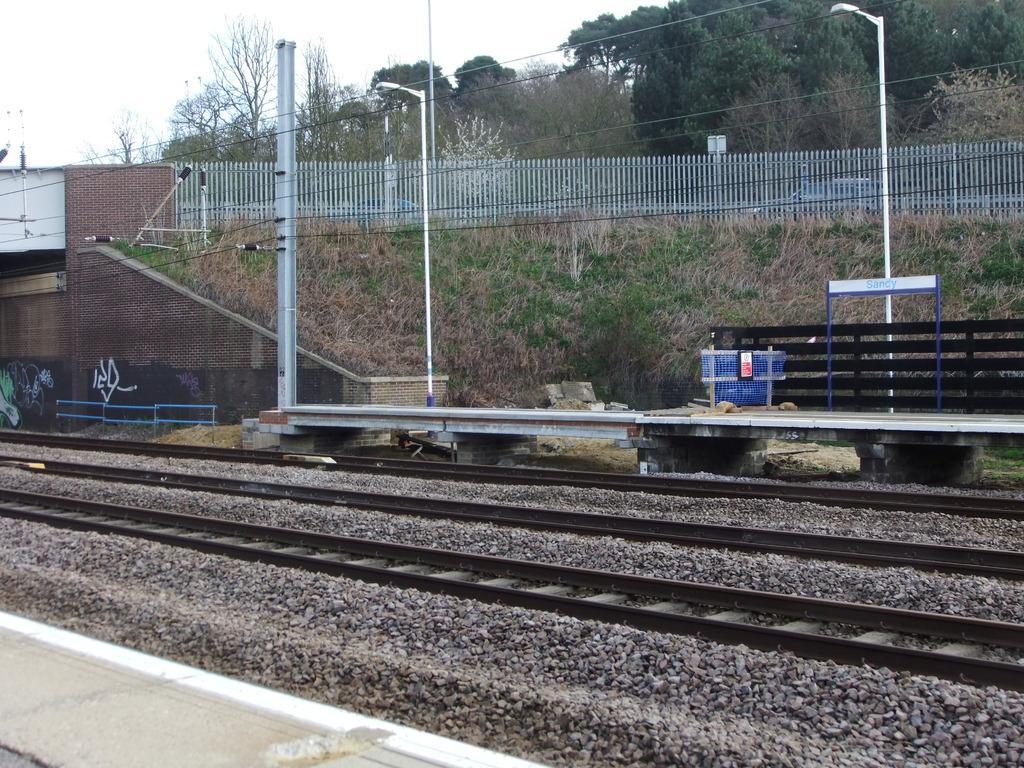How would you summarize this image in a sentence or two? In this image, we can see railway tracks, we can see the fence, there are some street lights, we can see some trees, on the left side there is a platform, at the top we can see the sky. 